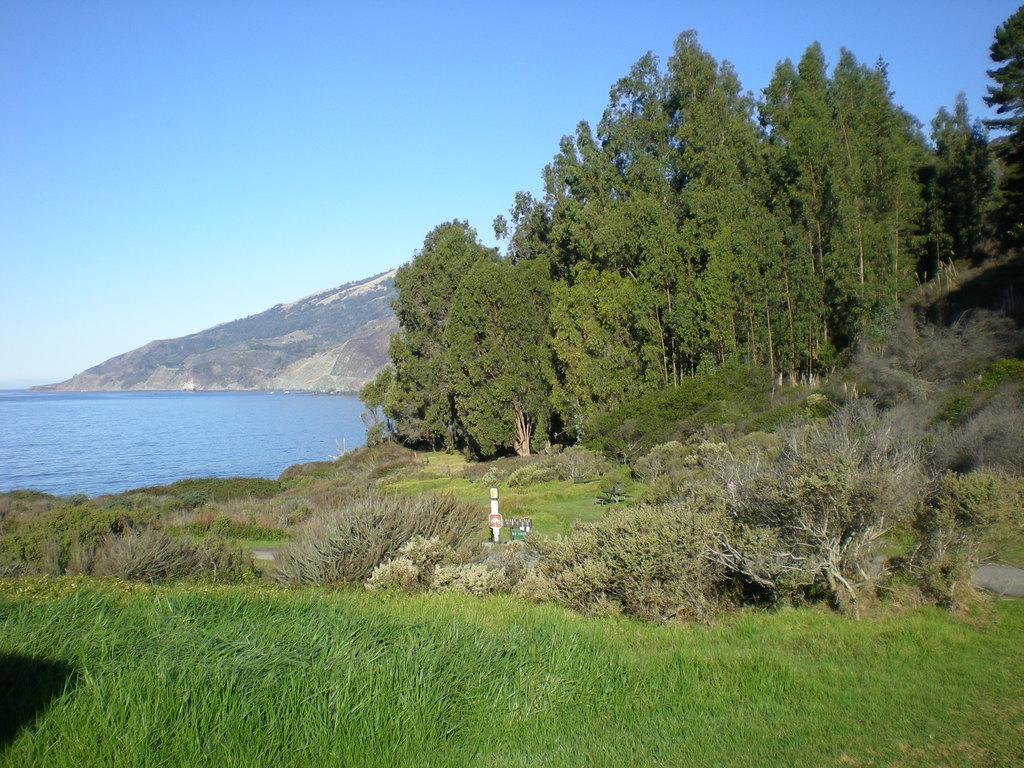Describe this image in one or two sentences. In this image I can observe grass in the foreground. In the middle there are some plants and trees. On left side of the image, there is a river and on the background I can observe sky and a mountain. 